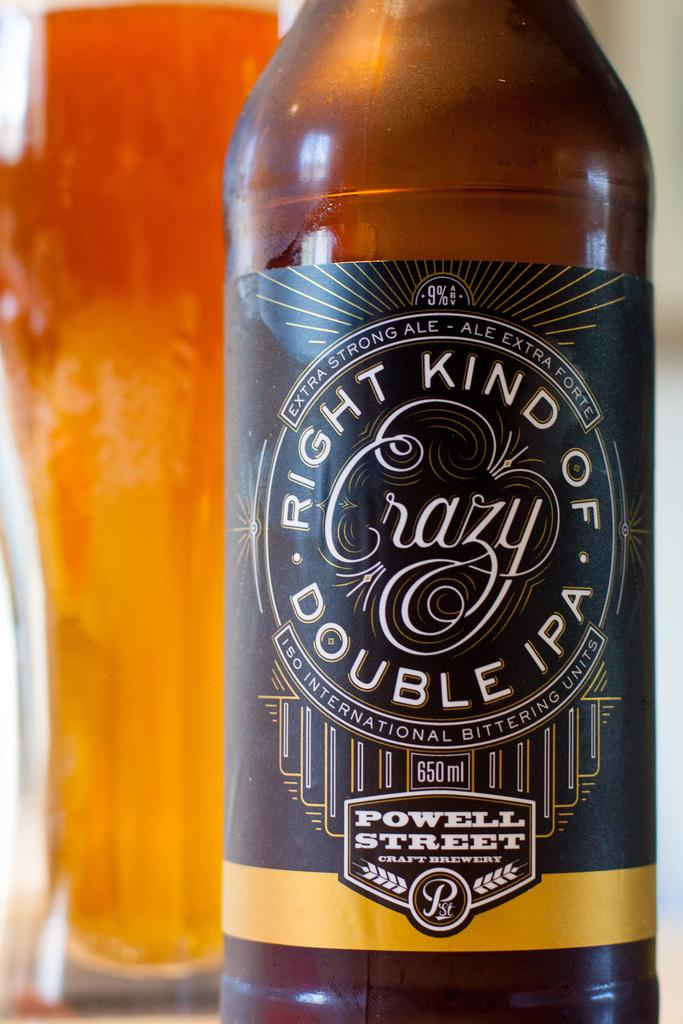<image>
Write a terse but informative summary of the picture. A bottle of double IPA beer that is called Crazy. 